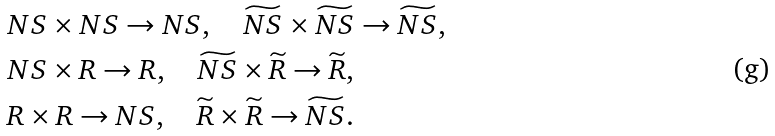<formula> <loc_0><loc_0><loc_500><loc_500>& N S \times N S \to N S , \quad \widetilde { N S } \times \widetilde { N S } \to \widetilde { N S } , \\ & N S \times R \to R , \quad \widetilde { N S } \times \widetilde { R } \to \widetilde { R } , \\ & R \times R \to N S , \quad \widetilde { R } \times \widetilde { R } \to \widetilde { N S } .</formula> 